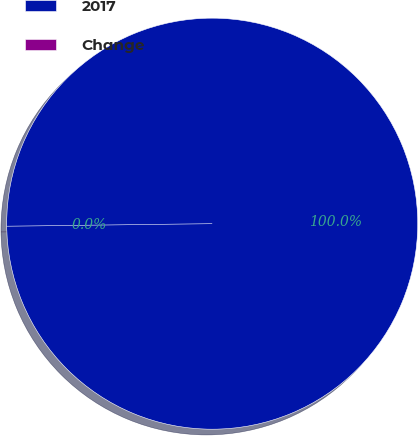<chart> <loc_0><loc_0><loc_500><loc_500><pie_chart><fcel>2017<fcel>Change<nl><fcel>100.0%<fcel>0.0%<nl></chart> 